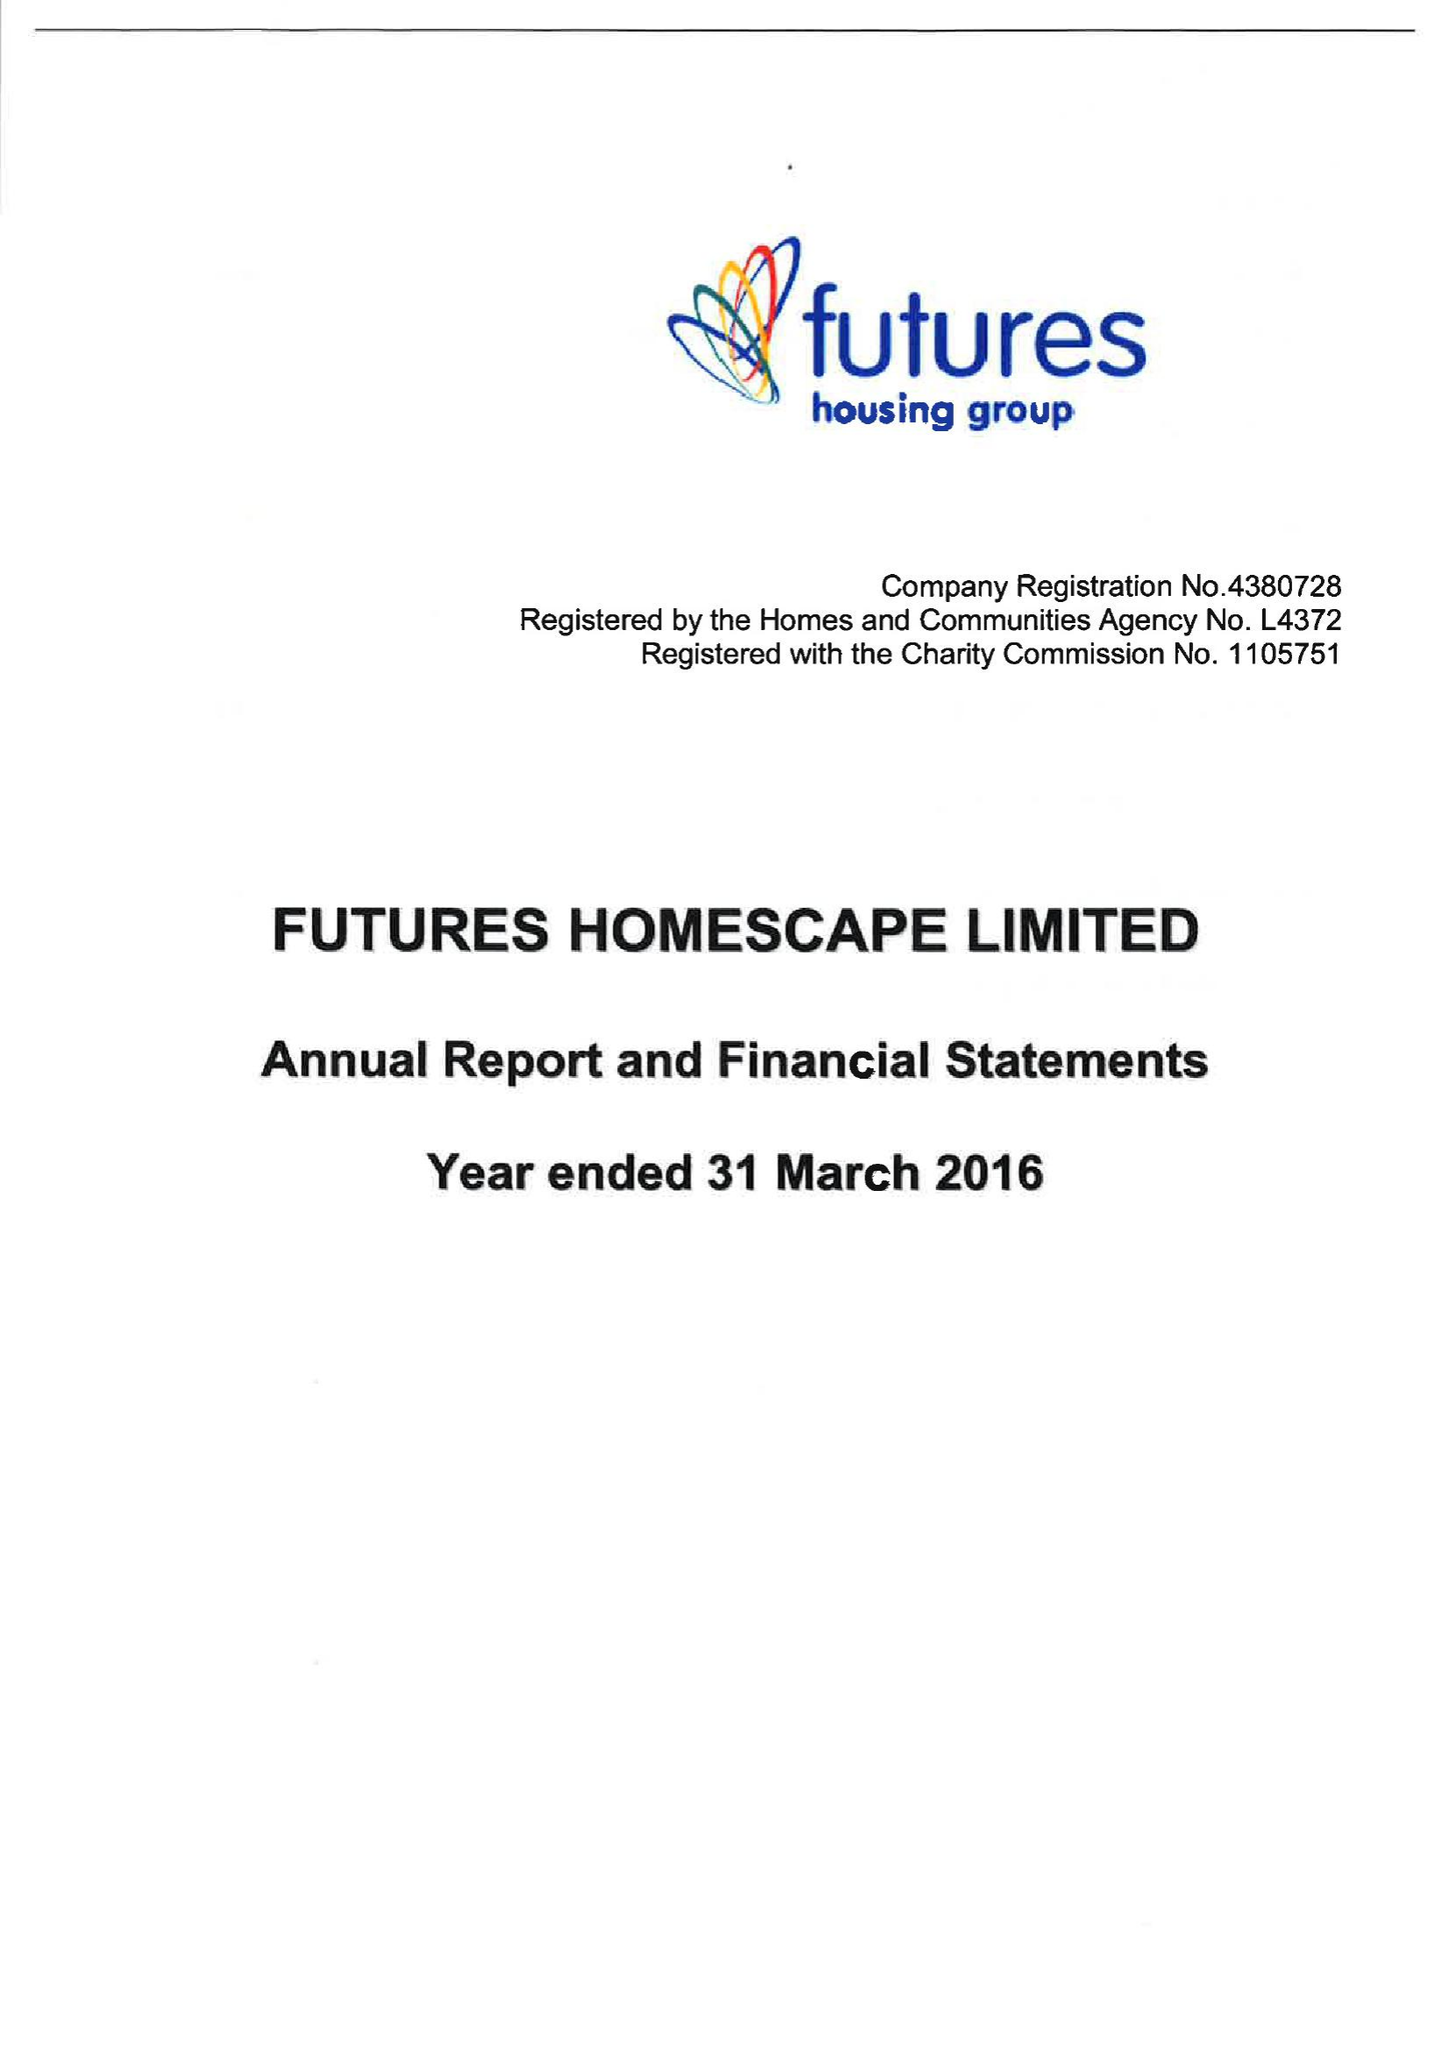What is the value for the charity_name?
Answer the question using a single word or phrase. Futures Homescape Ltd. 